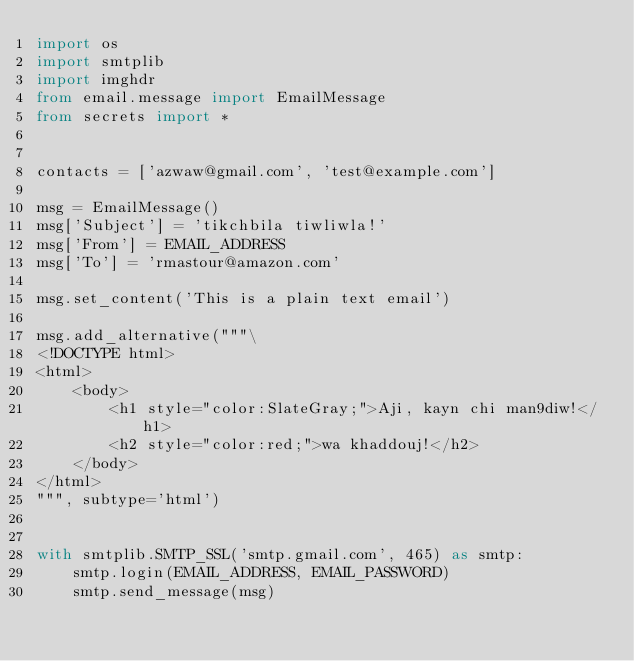<code> <loc_0><loc_0><loc_500><loc_500><_Python_>import os
import smtplib
import imghdr
from email.message import EmailMessage
from secrets import *


contacts = ['azwaw@gmail.com', 'test@example.com']

msg = EmailMessage()
msg['Subject'] = 'tikchbila tiwliwla!'
msg['From'] = EMAIL_ADDRESS
msg['To'] = 'rmastour@amazon.com'

msg.set_content('This is a plain text email')

msg.add_alternative("""\
<!DOCTYPE html>
<html>
    <body>
        <h1 style="color:SlateGray;">Aji, kayn chi man9diw!</h1>
        <h2 style="color:red;">wa khaddouj!</h2>
    </body>
</html>
""", subtype='html')


with smtplib.SMTP_SSL('smtp.gmail.com', 465) as smtp:
    smtp.login(EMAIL_ADDRESS, EMAIL_PASSWORD)
    smtp.send_message(msg)
</code> 